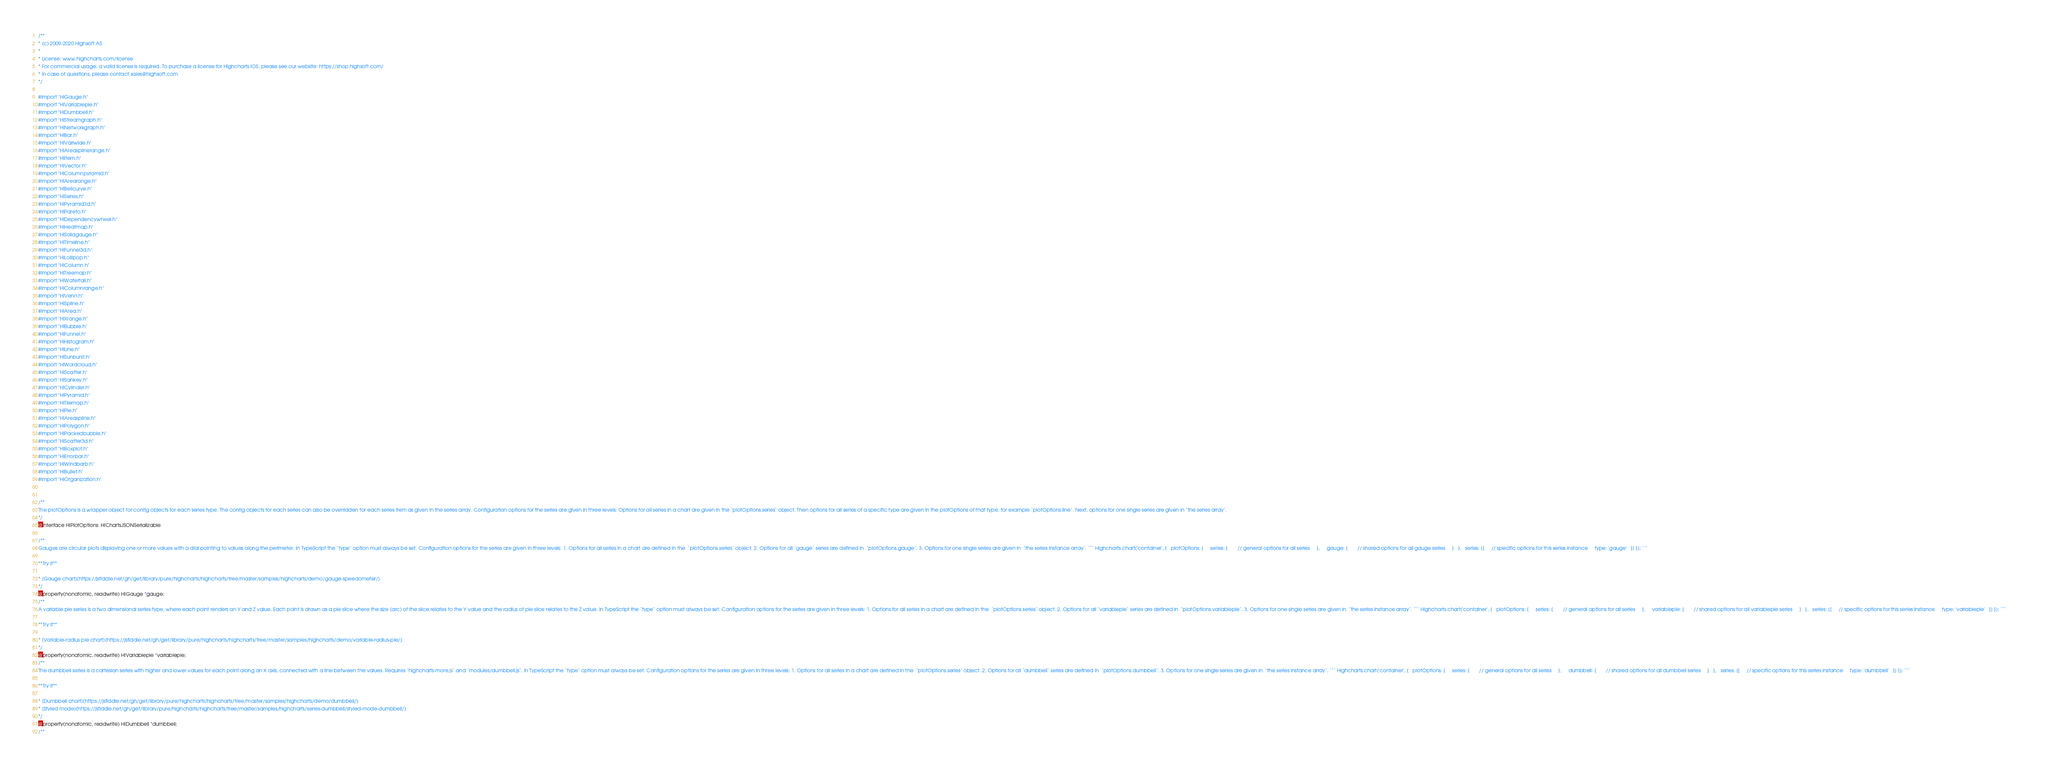Convert code to text. <code><loc_0><loc_0><loc_500><loc_500><_C_>/**
* (c) 2009-2020 Highsoft AS
*
* License: www.highcharts.com/license
* For commercial usage, a valid license is required. To purchase a license for Highcharts iOS, please see our website: https://shop.highsoft.com/
* In case of questions, please contact sales@highsoft.com
*/

#import "HIGauge.h"
#import "HIVariablepie.h"
#import "HIDumbbell.h"
#import "HIStreamgraph.h"
#import "HINetworkgraph.h"
#import "HIBar.h"
#import "HIVariwide.h"
#import "HIAreasplinerange.h"
#import "HIItem.h"
#import "HIVector.h"
#import "HIColumnpyramid.h"
#import "HIArearange.h"
#import "HIBellcurve.h"
#import "HISeries.h"
#import "HIPyramid3d.h"
#import "HIPareto.h"
#import "HIDependencywheel.h"
#import "HIHeatmap.h"
#import "HISolidgauge.h"
#import "HITimeline.h"
#import "HIFunnel3d.h"
#import "HILollipop.h"
#import "HIColumn.h"
#import "HITreemap.h"
#import "HIWaterfall.h"
#import "HIColumnrange.h"
#import "HIVenn.h"
#import "HISpline.h"
#import "HIArea.h"
#import "HIXrange.h"
#import "HIBubble.h"
#import "HIFunnel.h"
#import "HIHistogram.h"
#import "HILine.h"
#import "HISunburst.h"
#import "HIWordcloud.h"
#import "HIScatter.h"
#import "HISankey.h"
#import "HICylinder.h"
#import "HIPyramid.h"
#import "HITilemap.h"
#import "HIPie.h"
#import "HIAreaspline.h"
#import "HIPolygon.h"
#import "HIPackedbubble.h"
#import "HIScatter3d.h"
#import "HIBoxplot.h"
#import "HIErrorbar.h"
#import "HIWindbarb.h"
#import "HIBullet.h"
#import "HIOrganization.h"


/**
The plotOptions is a wrapper object for config objects for each series type. The config objects for each series can also be overridden for each series item as given in the series array. Configuration options for the series are given in three levels. Options for all series in a chart are given in the `plotOptions.series` object. Then options for all series of a specific type are given in the plotOptions of that type, for example `plotOptions.line`. Next, options for one single series are given in `the series array`.
*/
@interface HIPlotOptions: HIChartsJSONSerializable

/**
Gauges are circular plots displaying one or more values with a dial pointing to values along the perimeter. In TypeScript the `type` option must always be set. Configuration options for the series are given in three levels: 1. Options for all series in a chart are defined in the  `plotOptions.series` object. 2. Options for all `gauge` series are defined in  `plotOptions.gauge`. 3. Options for one single series are given in  `the series instance array`. ``` Highcharts.chart('container', {   plotOptions: {     series: {       // general options for all series     },     gauge: {       // shared options for all gauge series     }   },   series: [{     // specific options for this series instance     type: 'gauge'   }] }); ```       

**Try it**

* [Gauge chart](https://jsfiddle.net/gh/get/library/pure/highcharts/highcharts/tree/master/samples/highcharts/demo/gauge-speedometer/)
*/
@property(nonatomic, readwrite) HIGauge *gauge;
/**
A variable pie series is a two dimensional series type, where each point renders an Y and Z value. Each point is drawn as a pie slice where the size (arc) of the slice relates to the Y value and the radius of pie slice relates to the Z value. In TypeScript the `type` option must always be set. Configuration options for the series are given in three levels: 1. Options for all series in a chart are defined in the  `plotOptions.series` object. 2. Options for all `variablepie` series are defined in  `plotOptions.variablepie`. 3. Options for one single series are given in  `the series instance array`. ``` Highcharts.chart('container', {   plotOptions: {     series: {       // general options for all series     },     variablepie: {       // shared options for all variablepie series     }   },   series: [{     // specific options for this series instance     type: 'variablepie'   }] }); ```       

**Try it**

* [Variable-radius pie chart](https://jsfiddle.net/gh/get/library/pure/highcharts/highcharts/tree/master/samples/highcharts/demo/variable-radius-pie/)
*/
@property(nonatomic, readwrite) HIVariablepie *variablepie;
/**
The dumbbell series is a cartesian series with higher and lower values for each point along an X axis, connected with a line between the values. Requires `highcharts-more.js` and `modules/dumbbell.js`. In TypeScript the `type` option must always be set. Configuration options for the series are given in three levels: 1. Options for all series in a chart are defined in the  `plotOptions.series` object. 2. Options for all `dumbbell` series are defined in  `plotOptions.dumbbell`. 3. Options for one single series are given in  `the series instance array`. ``` Highcharts.chart('container', {   plotOptions: {     series: {       // general options for all series     },     dumbbell: {       // shared options for all dumbbell series     }   },   series: [{     // specific options for this series instance     type: 'dumbbell'   }] }); ```       

**Try it**

* [Dumbbell chart](https://jsfiddle.net/gh/get/library/pure/highcharts/highcharts/tree/master/samples/highcharts/demo/dumbbell/)
* [Styled mode](https://jsfiddle.net/gh/get/library/pure/highcharts/highcharts/tree/master/samples/highcharts/series-dumbbell/styled-mode-dumbbell/)
*/
@property(nonatomic, readwrite) HIDumbbell *dumbbell;
/**</code> 